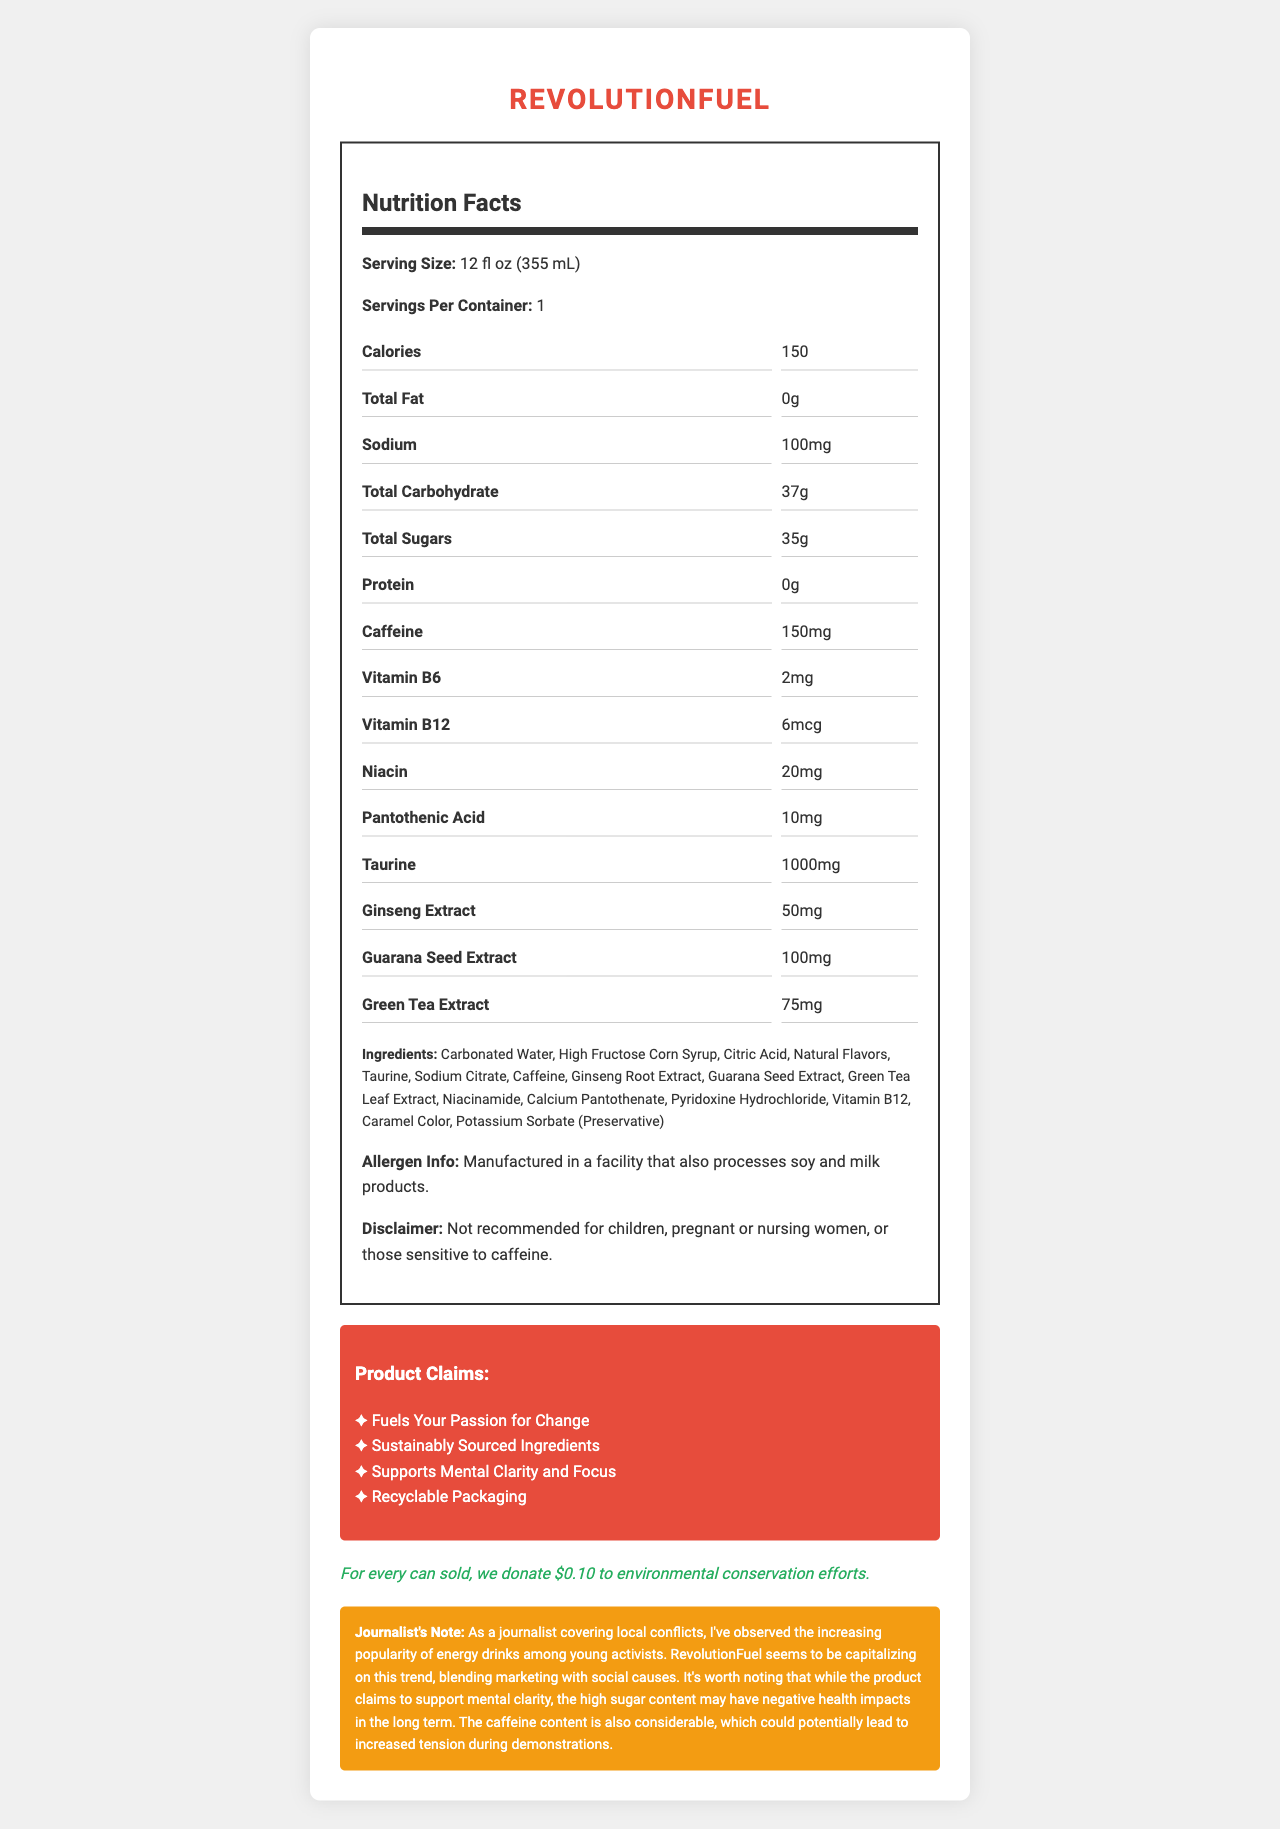How many calories are in one serving of RevolutionFuel? The label lists the number of calories directly in the Nutrition Facts section as 150.
Answer: 150 What is the serving size for RevolutionFuel? The serving size is explicitly mentioned as "12 fl oz (355 mL)" in the Nutrition Facts section.
Answer: 12 fl oz (355 mL) Name three ingredients found in RevolutionFuel. The ingredients list provided includes Carbonated Water, High Fructose Corn Syrup, and Taurine among others.
Answer: Carbonated Water, High Fructose Corn Syrup, Taurine How much caffeine is in one serving of RevolutionFuel? The amount of caffeine per serving is listed as 150mg in the Nutrition Facts.
Answer: 150mg What is the sodium content of RevolutionFuel? The sodium content is specified as 100mg in the Nutrition Facts section.
Answer: 100mg Which of the following vitamins are included in RevolutionFuel? A. Vitamin C B. Vitamin A C. Vitamin B6 D. Folate The Nutrition Facts section lists Vitamin B6 as one of the included vitamins.
Answer: C Which of these claims is NOT made by RevolutionFuel? I. Supports Mental Clarity and Focus II. Provides Hydration III. Recyclable Packaging IV. Fuels Your Passion for Change "Provides Hydration" is not among the marketing claims listed in the document. The other options are part of the claims.
Answer: II Does RevolutionFuel contain any protein? The Nutrition Facts section shows that the protein content is 0g.
Answer: No Is RevolutionFuel recommended for children? The disclaimer states that it is not recommended for children.
Answer: No Summarize the main idea of the document. The document provides detailed nutritional information, ingredients, marketing claims, and includes disclaimers and a journalistic note highlighting potential health concerns and the target audience.
Answer: RevolutionFuel is an energy drink marketed towards young activists. It contains various ingredients including caffeine, vitamins, and several herbal extracts. The product promotes claims like supporting mental clarity and sustainability, and donates part of its revenue to environmental conservation. However, the high sugar and caffeine content could have negative health effects. What is the source of sweetness in RevolutionFuel? The document does not specify whether the High Fructose Corn Syrup or another ingredient is the primary source of sweetness.
Answer: Not enough information 